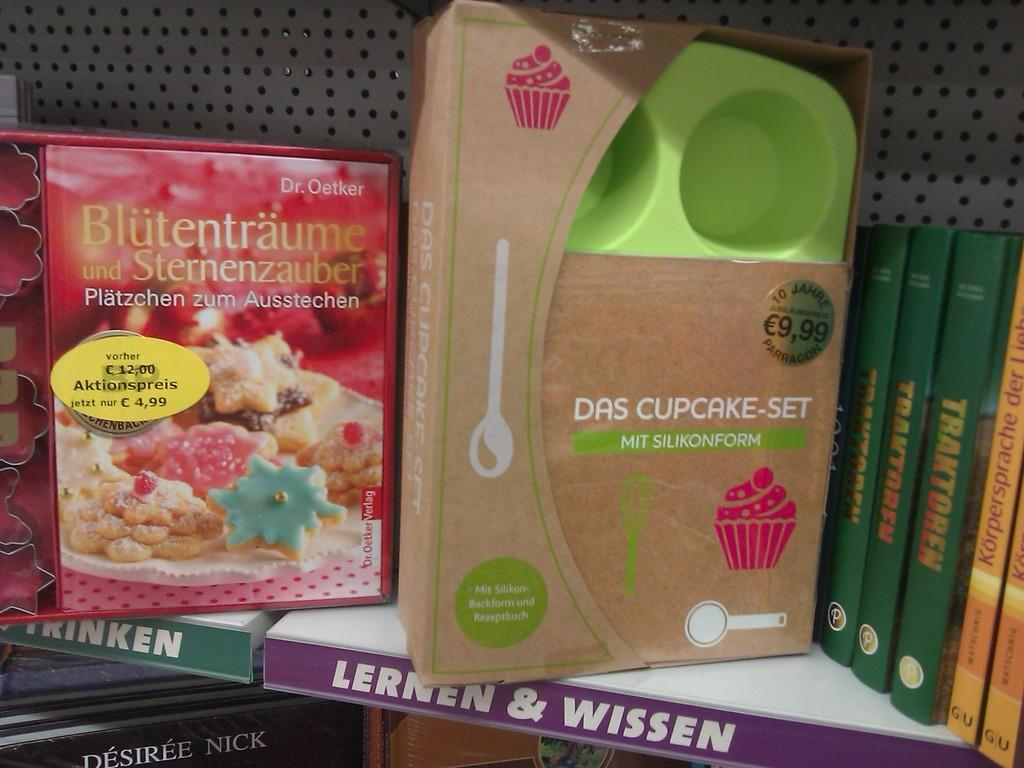<image>
Write a terse but informative summary of the picture. A shelf in a store with cookbooks and a silicone cupcake set which sells for 9,99 euros. 